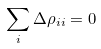<formula> <loc_0><loc_0><loc_500><loc_500>\sum _ { i } \Delta \rho _ { i i } = 0</formula> 